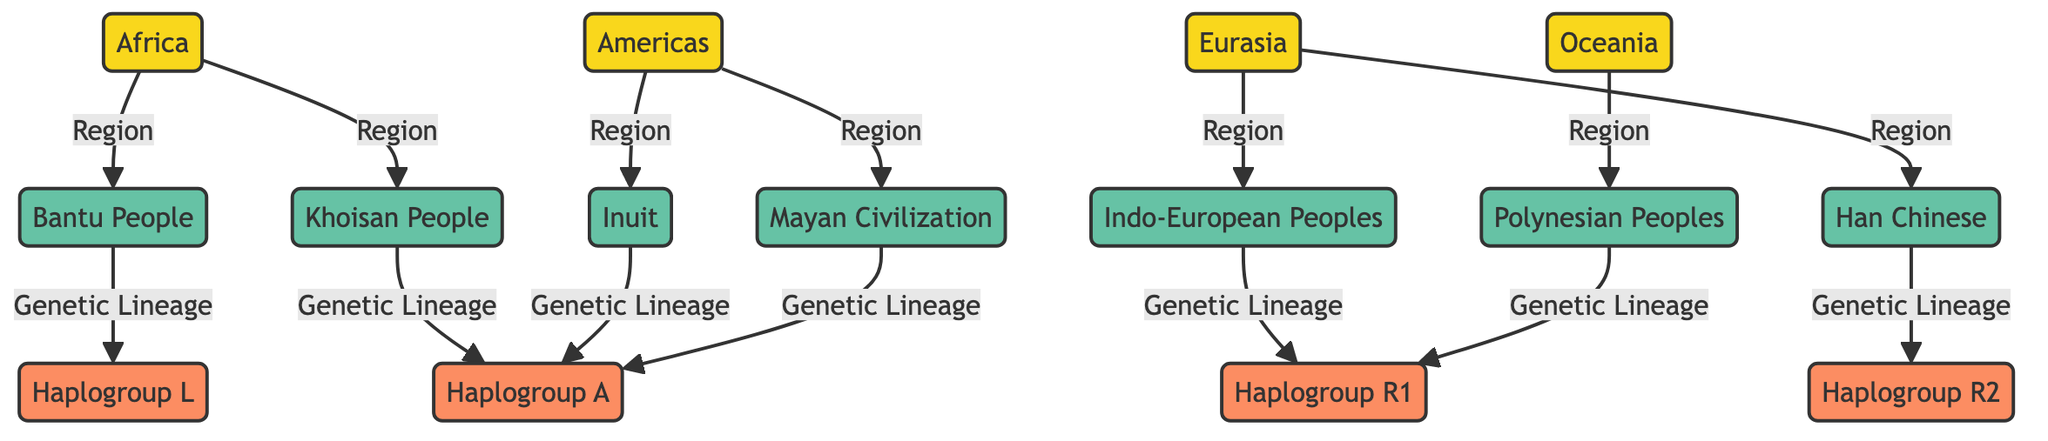What cultures are found in Africa? The diagram shows two cultures listed under Africa: the Bantu People and the Khoisan People.
Answer: Bantu People, Khoisan People Which haplogroup is associated with the Han Chinese? The diagram indicates that the genetic lineage for Han Chinese is Haplogroup R2.
Answer: Haplogroup R2 How many cultures are represented in the Americas? The diagram lists two cultures in the Americas: the Inuit and the Mayan Civilization. Therefore, the total number is two.
Answer: 2 Which haplogroup is linked to Polynesian Peoples? According to the diagram, the Polynesian Peoples are associated with Haplogroup R1.
Answer: Haplogroup R1 What is the connection between the Bantu People and their haplogroup? The diagram shows a direct line from the Bantu People to Haplogroup L, indicating that it is their genetic lineage.
Answer: Haplogroup L How many total regions are depicted in the diagram? The diagram illustrates four regions: Africa, Eurasia, Americas, and Oceania. This gives a total count of four regions.
Answer: 4 Which genetic lineage do both the Inuit and the Mayan share? Upon reviewing the diagram, it is clear that both cultures are linked to Haplogroup A.
Answer: Haplogroup A What culture in Eurasia is represented alongside Haplogroup R1? The diagram shows that the Indo-European Peoples are linked to Haplogroup R1 in Eurasia.
Answer: Indo-European Peoples Which continent is associated with the Khoisan People? According to the diagram, the Khoisan People are specifically linked to the continent of Africa.
Answer: Africa 